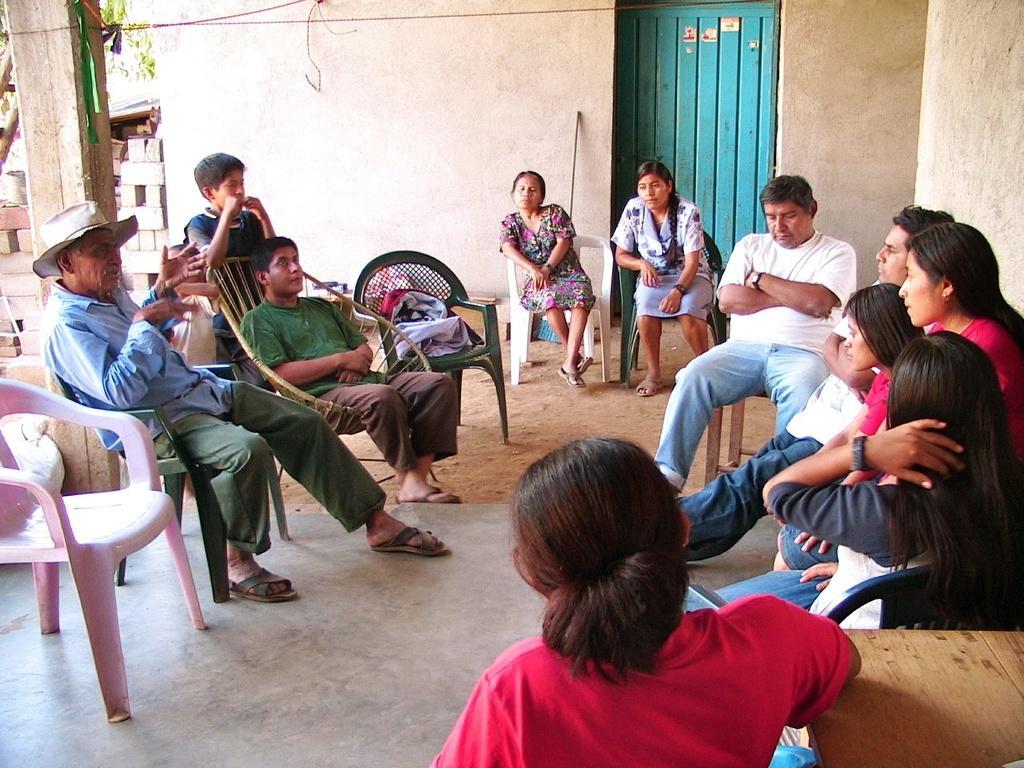Describe this image in one or two sentences. In this picture we can see a group of people sitting on chairs and on chairs we have a bag and in the background we can see wall, door, pillar, tree, wires. 